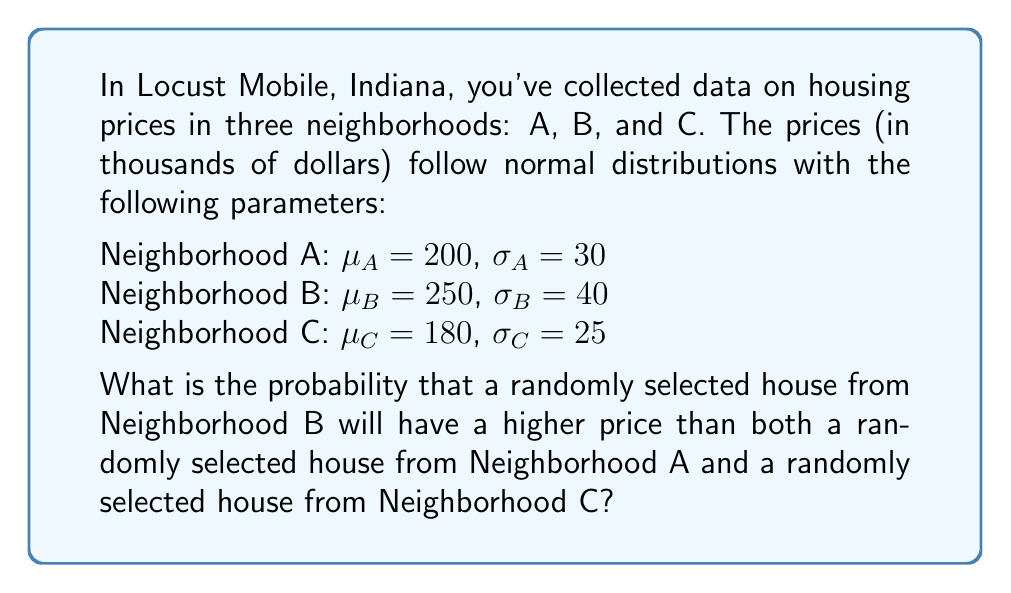Help me with this question. To solve this problem, we need to follow these steps:

1) First, we need to understand that we're looking for the probability that B > A and B > C simultaneously.

2) We can express this as: P(B > A and B > C) = P(B > max(A, C))

3) The difference between two normally distributed variables is also normally distributed. Let's define new variables:

   D1 = B - A
   D2 = B - C

4) The parameters for these new distributions are:

   For D1: 
   $\mu_{D1} = \mu_B - \mu_A = 250 - 200 = 50$
   $\sigma_{D1} = \sqrt{\sigma_B^2 + \sigma_A^2} = \sqrt{40^2 + 30^2} = 50$

   For D2:
   $\mu_{D2} = \mu_B - \mu_C = 250 - 180 = 70$
   $\sigma_{D2} = \sqrt{\sigma_B^2 + \sigma_C^2} = \sqrt{40^2 + 25^2} = 47.17$

5) Now, we need to find P(D1 > 0 and D2 > 0)

6) This is equivalent to finding P(Z1 > -1 and Z2 > -1.48), where Z1 and Z2 are standard normal variables:

   $Z1 = \frac{D1 - \mu_{D1}}{\sigma_{D1}} = \frac{D1 - 50}{50}$
   $Z2 = \frac{D2 - \mu_{D2}}{\sigma_{D2}} = \frac{D2 - 70}{47.17}$

7) The correlation coefficient between Z1 and Z2 is:

   $\rho = \frac{\sigma_B^2}{\sigma_{D1}\sigma_{D2}} = \frac{40^2}{50 * 47.17} = 0.678$

8) To find P(Z1 > -1 and Z2 > -1.48) with correlation 0.678, we need to use a bivariate normal distribution function. This doesn't have a closed-form solution and typically requires numerical methods or lookup tables.

9) Using a statistical software or advanced calculator, we can find that this probability is approximately 0.8234.
Answer: 0.8234 